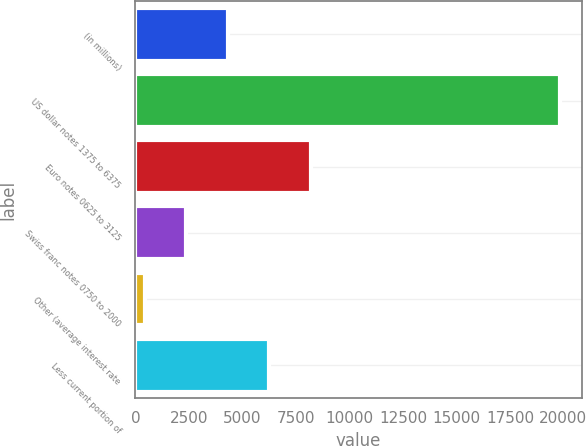Convert chart. <chart><loc_0><loc_0><loc_500><loc_500><bar_chart><fcel>(in millions)<fcel>US dollar notes 1375 to 6375<fcel>Euro notes 0625 to 3125<fcel>Swiss franc notes 0750 to 2000<fcel>Other (average interest rate<fcel>Less current portion of<nl><fcel>4313<fcel>19857<fcel>8199<fcel>2370<fcel>427<fcel>6256<nl></chart> 